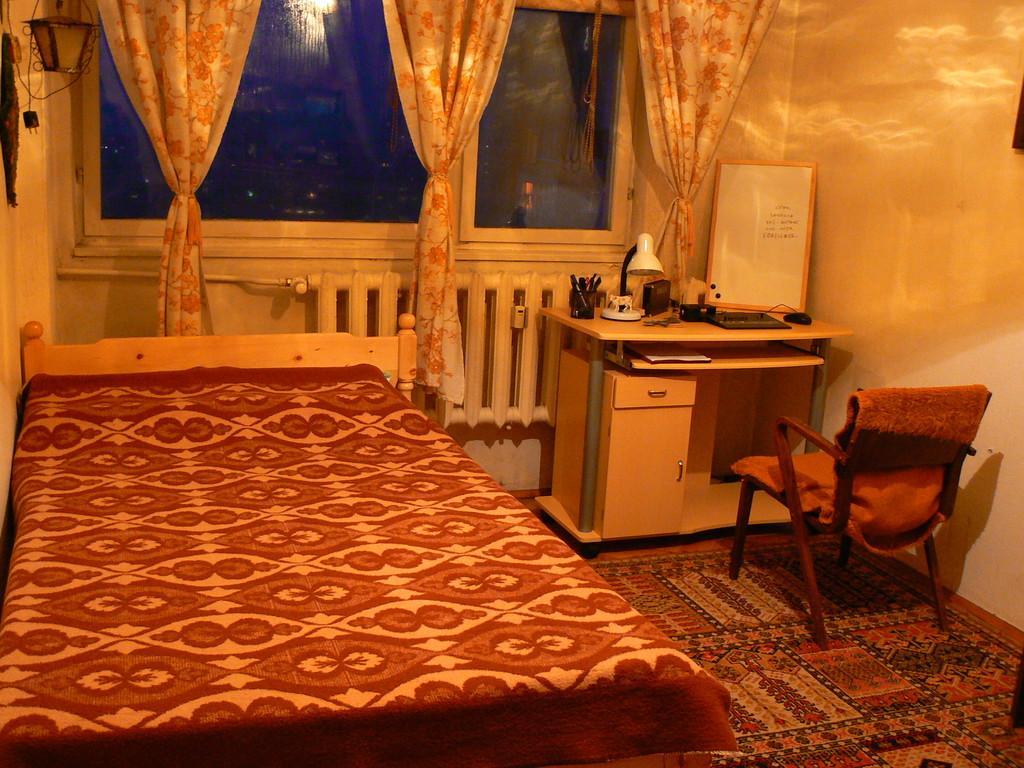Could you give a brief overview of what you see in this image? In this image I can see the bed. To the side of the bed I can see the chair and the table. On the table I can see the lamp, pens box, board and some objects. In the background there is a window to the wall. I can also see the curtains to the window. 